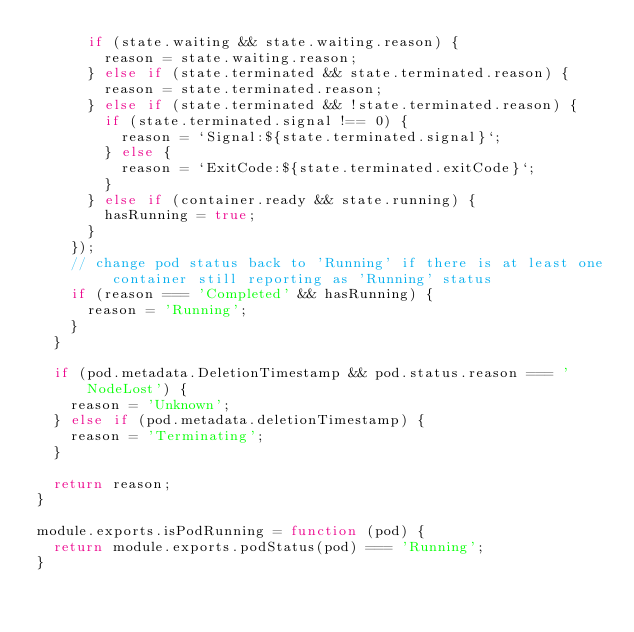<code> <loc_0><loc_0><loc_500><loc_500><_JavaScript_>      if (state.waiting && state.waiting.reason) {
        reason = state.waiting.reason;
      } else if (state.terminated && state.terminated.reason) {
        reason = state.terminated.reason;
      } else if (state.terminated && !state.terminated.reason) {
        if (state.terminated.signal !== 0) {
          reason = `Signal:${state.terminated.signal}`;
        } else {
          reason = `ExitCode:${state.terminated.exitCode}`;
        }
      } else if (container.ready && state.running) {
        hasRunning = true;
      }
    });
    // change pod status back to 'Running' if there is at least one container still reporting as 'Running' status
    if (reason === 'Completed' && hasRunning) {
      reason = 'Running';
    }
  }

  if (pod.metadata.DeletionTimestamp && pod.status.reason === 'NodeLost') {
    reason = 'Unknown';
  } else if (pod.metadata.deletionTimestamp) {
    reason = 'Terminating';
  }

  return reason;
}

module.exports.isPodRunning = function (pod) {
  return module.exports.podStatus(pod) === 'Running';
}
</code> 